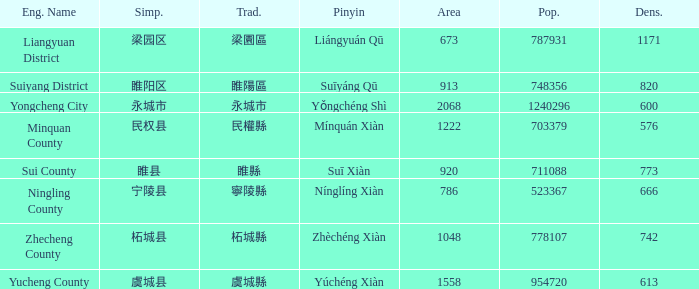What is the traditional form for 永城市? 永城市. 